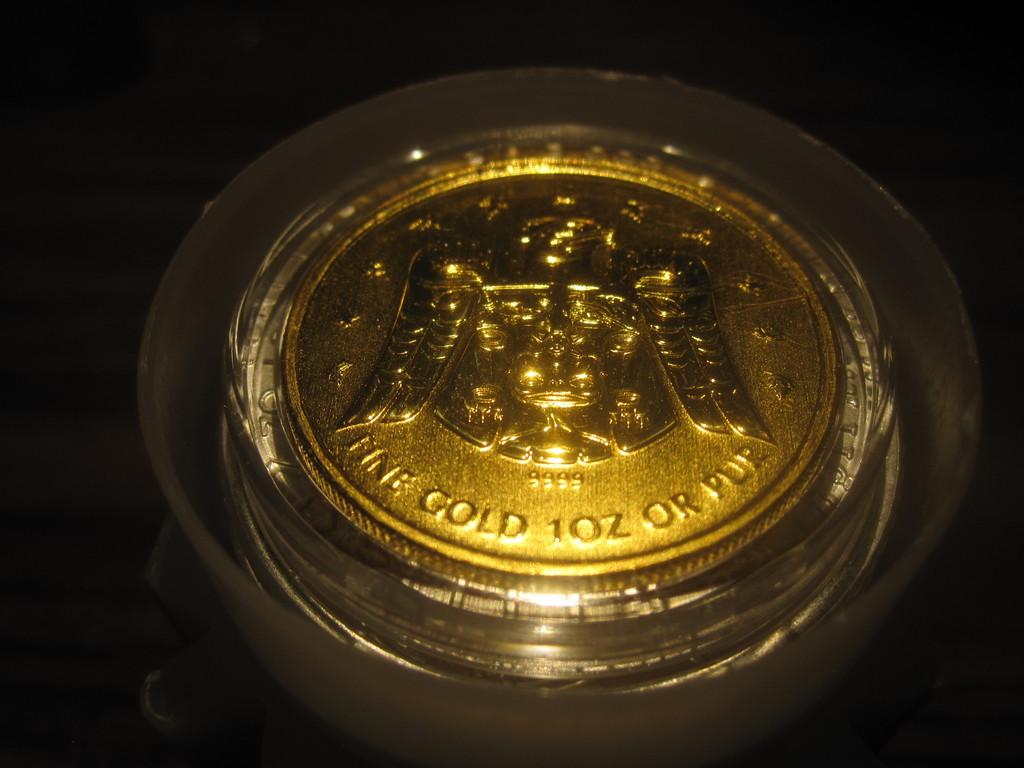<image>
Create a compact narrative representing the image presented. Gold coin that says Fine Gold 10z or Pur on it. 